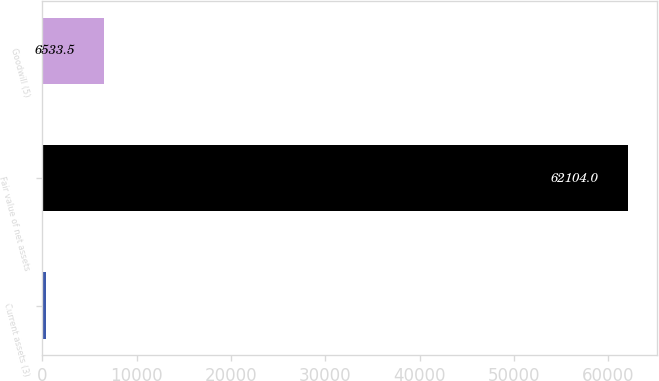Convert chart. <chart><loc_0><loc_0><loc_500><loc_500><bar_chart><fcel>Current assets (3)<fcel>Fair value of net assets<fcel>Goodwill (5)<nl><fcel>359<fcel>62104<fcel>6533.5<nl></chart> 